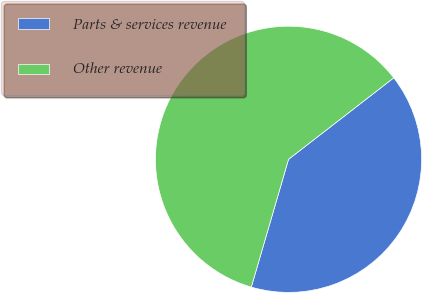<chart> <loc_0><loc_0><loc_500><loc_500><pie_chart><fcel>Parts & services revenue<fcel>Other revenue<nl><fcel>40.0%<fcel>60.0%<nl></chart> 